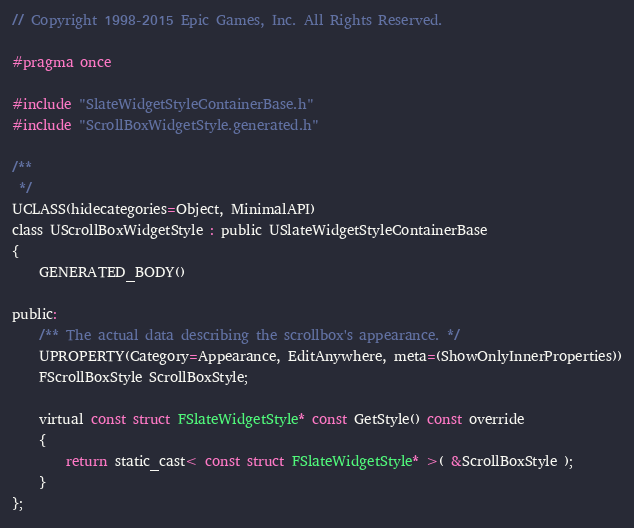<code> <loc_0><loc_0><loc_500><loc_500><_C_>// Copyright 1998-2015 Epic Games, Inc. All Rights Reserved.

#pragma once

#include "SlateWidgetStyleContainerBase.h"
#include "ScrollBoxWidgetStyle.generated.h"

/**
 */
UCLASS(hidecategories=Object, MinimalAPI)
class UScrollBoxWidgetStyle : public USlateWidgetStyleContainerBase
{
	GENERATED_BODY()

public:
	/** The actual data describing the scrollbox's appearance. */
	UPROPERTY(Category=Appearance, EditAnywhere, meta=(ShowOnlyInnerProperties))
	FScrollBoxStyle ScrollBoxStyle;

	virtual const struct FSlateWidgetStyle* const GetStyle() const override
	{
		return static_cast< const struct FSlateWidgetStyle* >( &ScrollBoxStyle );
	}
};
</code> 